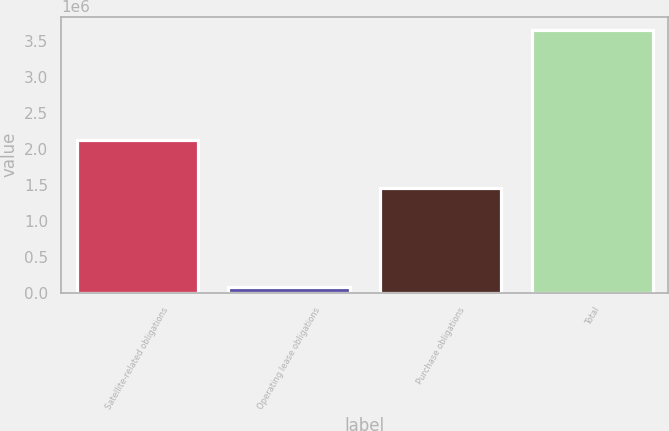Convert chart. <chart><loc_0><loc_0><loc_500><loc_500><bar_chart><fcel>Satellite-related obligations<fcel>Operating lease obligations<fcel>Purchase obligations<fcel>Total<nl><fcel>2.11767e+06<fcel>84000<fcel>1.44918e+06<fcel>3.65086e+06<nl></chart> 